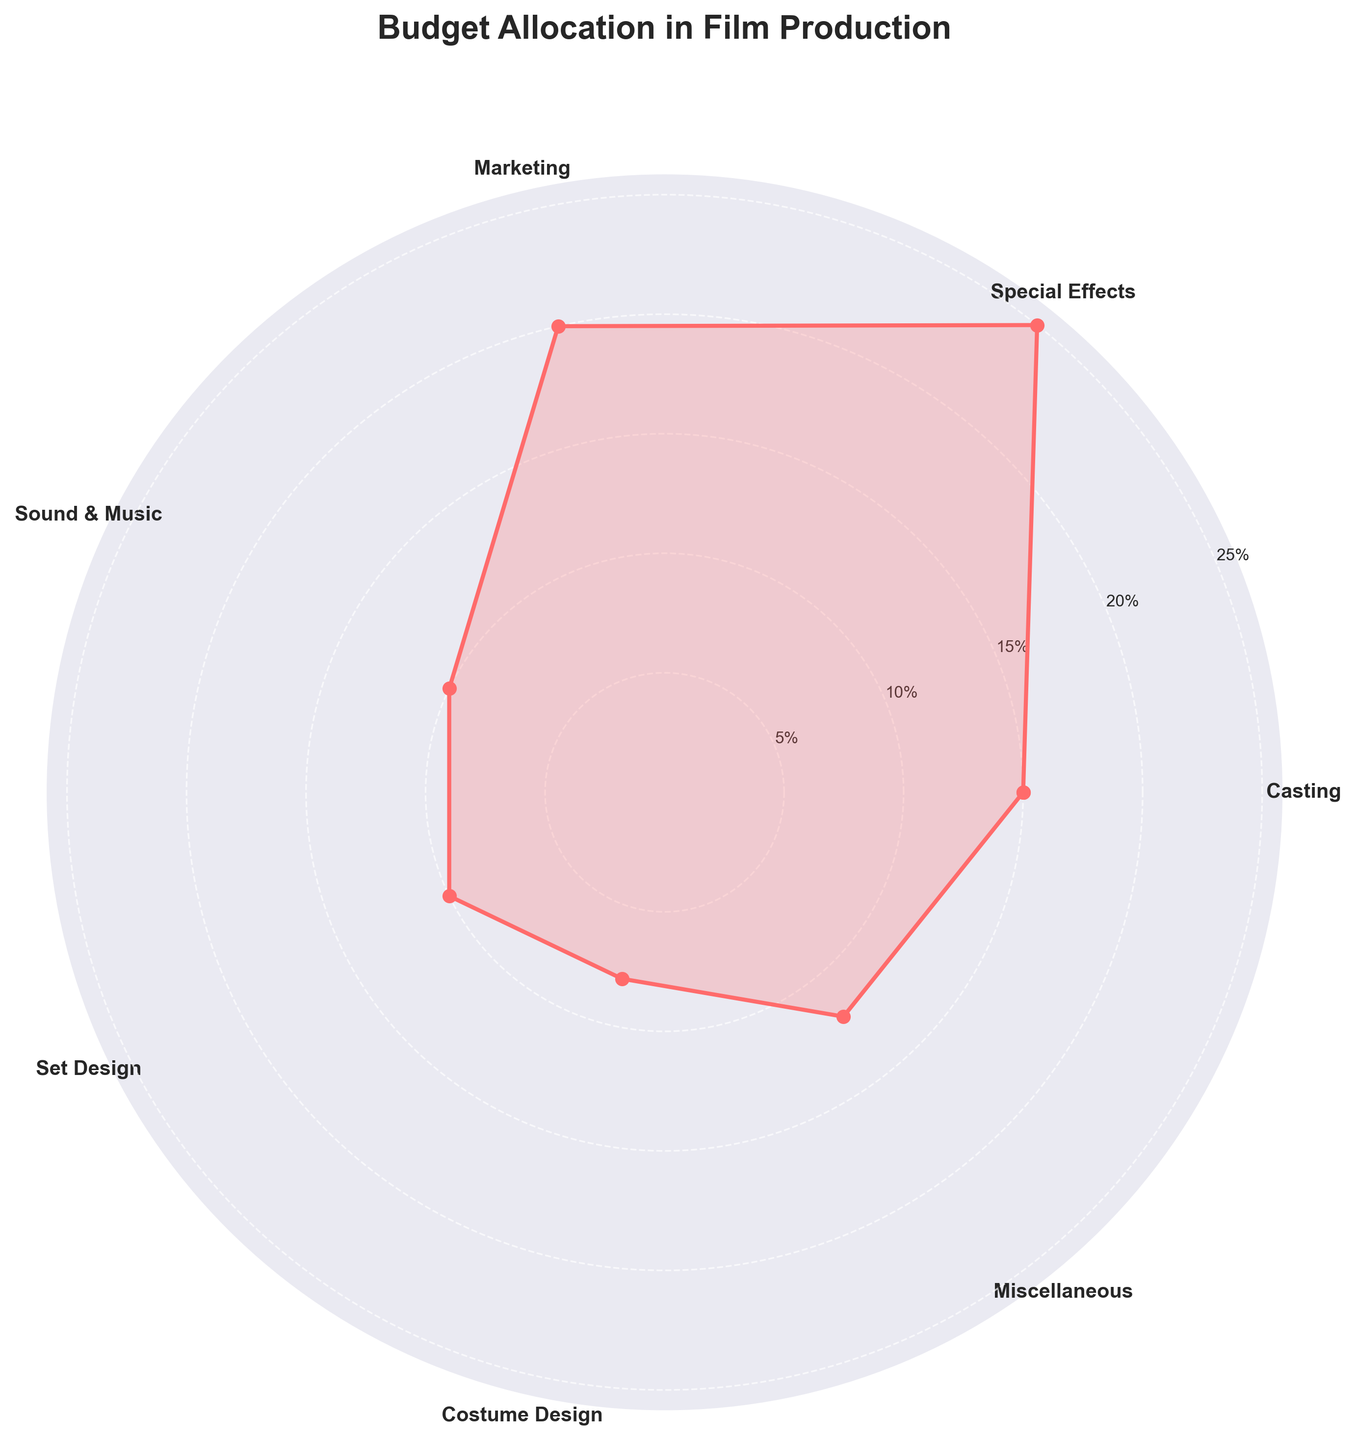What's the title of the chart? The title is located at the top of the chart, usually in bold text to differentiate it from other labels or annotations. In this case, it reads "Budget Allocation in Film Production".
Answer: Budget Allocation in Film Production Which department has the highest budget allocation? By examining the chart, the department with the furthest point from the center represents the highest allocation. This corresponds to Special Effects, positioned at the 25% mark.
Answer: Special Effects What is the budget percentage allocated to Marketing? Look for the department labeled "Marketing" along the outer circle of the chart and trace the corresponding radial line to its length. Marketing is noted at the 20% mark.
Answer: 20% Compare the allocation percentages for Special Effects and Casting. Which is higher and by how much? Special Effects is allocated 25%, and Casting is allocated 15%. The difference in their allocation is 25% - 15%. Therefore, Special Effects has 10% more allocation than Casting.
Answer: Special Effects by 10% Which departments share the same budget allocation? Check for departments whose radial lines reach the same distance from the center of the chart. Both Sound & Music and Set Design reach 10%, indicating equal budget allocations.
Answer: Sound & Music and Set Design What's the combined budget allocation for Costume Design and Miscellaneous? Add the allocation percentages for Costume Design (8%) and Miscellaneous (12%). The combined total is 8% + 12% = 20%.
Answer: 20% If you distribute an additional 5% equally among all departments, what will be the new budget percentage for Set Design? Set Design initially has 10%. Distributing an additional 5% equally among 7 departments means each gets 5% / 7 ≈ 0.71%. Adding this to Set Design's initial allocation: 10% + 0.71% ≈ 10.71%.
Answer: ~10.71% What is the total allocation percentage for the first half of the departments in a clockwise direction starting from Casting? The first half includes Casting, Special Effects, Marketing, and Sound & Music, totaling: 15% + 25% + 20% + 10% = 70%.
Answer: 70% What is the smallest budget allocation percentage visible on the chart? By comparing the distances of each department's radial line from the center, Costume Design has the smallest allocation at 8%.
Answer: 8% What is the average budget allocation across all departments? Sum all the allocation percentages and divide by the number of departments: (15% + 25% + 20% + 10% + 10% + 8% + 12%) / 7 = 100% / 7 ≈ 14.29%.
Answer: ~14.29% 